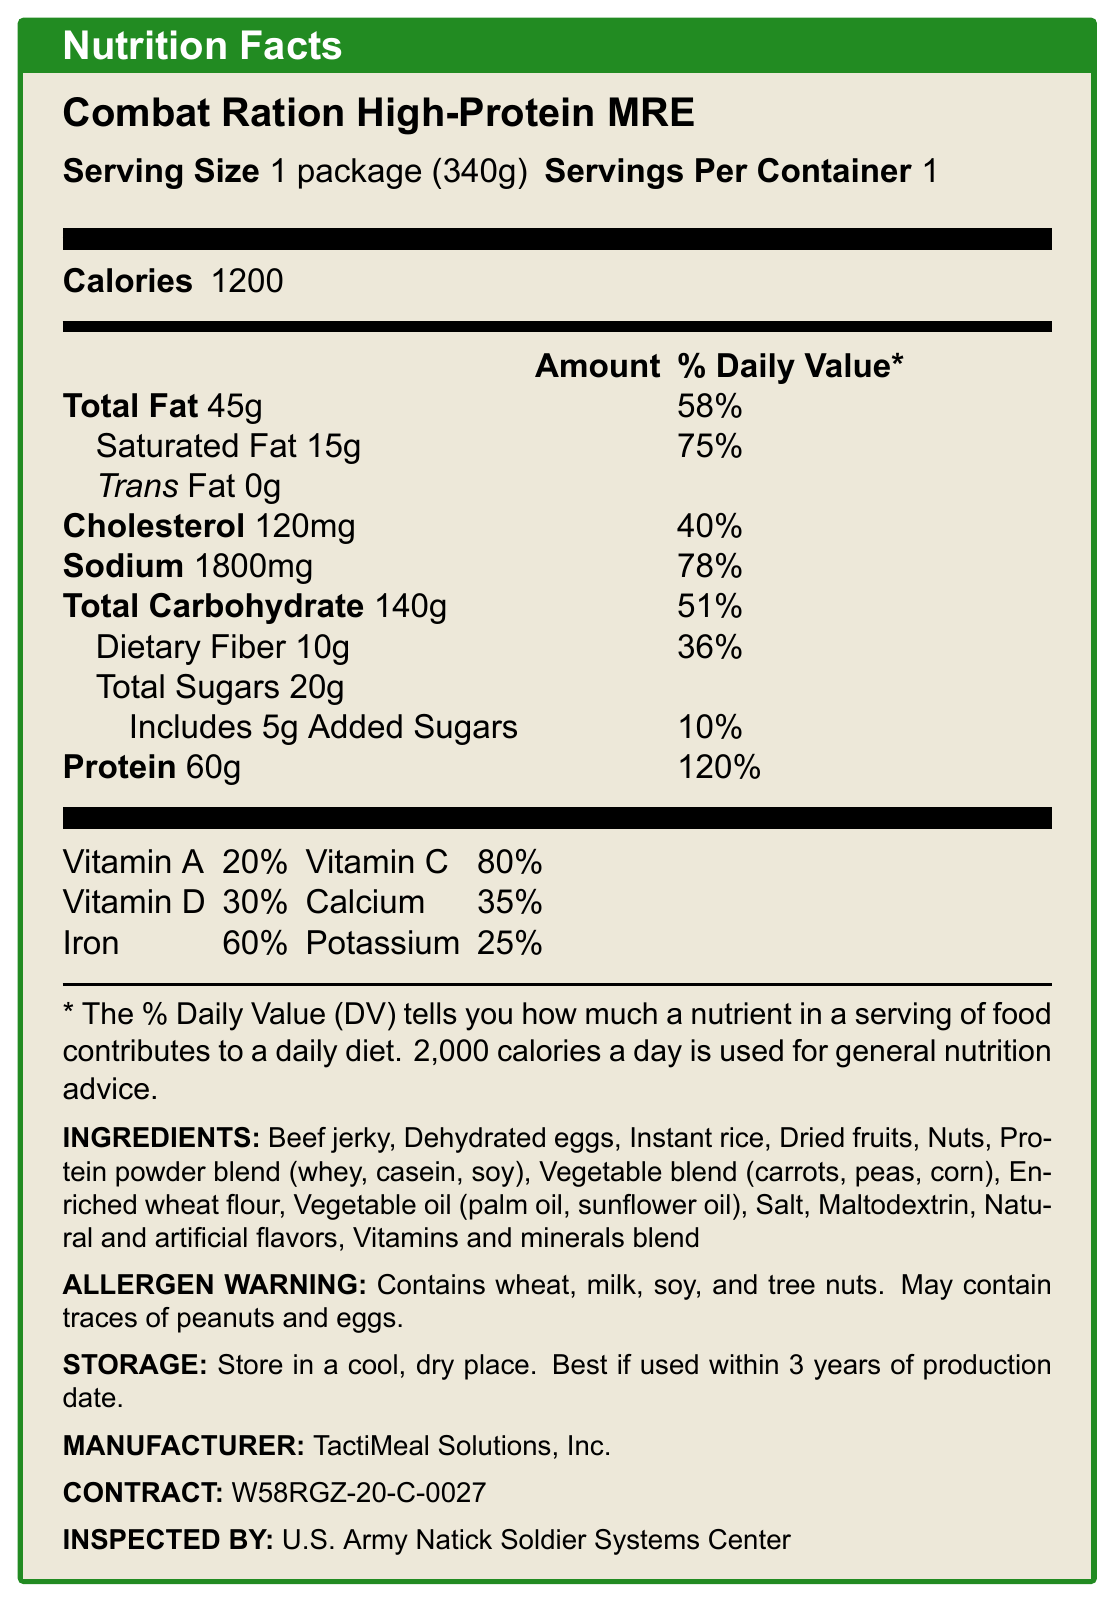what is the serving size of the Combat Ration High-Protein MRE? The document specifies that the serving size is 1 package (340g).
Answer: 1 package (340g) how many calories are in one serving of the Combat Ration High-Protein MRE? The document lists the calories per serving as 1200.
Answer: 1200 what is the total fat content in one serving, and what percentage of the daily value does it represent? The document states the total fat content as 45g, which represents 58% of the daily value.
Answer: 45g, 58% what is the main source of protein in the MRE? The ingredient list shows protein powder blend (whey, casein, soy) as a main source of protein.
Answer: Protein powder blend (whey, casein, soy) how much sodium does the MRE contain, and what percentage of the daily value does this represent? The document specifies the sodium content as 1800mg, which is 78% of the daily value.
Answer: 1800mg, 78% which vitamins are particularly abundant in this MRE? The document indicates that Vitamin C is at 80%, making it the most abundant vitamin listed.
Answer: Vitamin C how many grams of dietary fiber does the MRE contain? A. 5g B. 10g C. 15g D. 20g The document states that the MRE contains 10g of dietary fiber.
Answer: B. 10g what is the percentage of daily value for calcium provided by this MRE? A. 20% B. 35% C. 60% D. 25% The document shows that the percentage of the daily value for calcium is 35%.
Answer: B. 35% does the MRE contain trans fat? The document states the trans fat content as 0g.
Answer: No is the MRE designed to withstand extreme temperature conditions? The document mentions that it is heat-stable in various climate conditions and can resist temperatures from -60°F to 120°F.
Answer: Yes how long is the shelf life of the MRE at 80°F? The document states that the shelf life of the MRE at 80°F is a minimum of 3 years.
Answer: Minimum 3 years describe the purpose and special features of the Combat Ration High-Protein MRE. The document outlines several features, including sustained energy supply, essential vitamins and minerals, compactness, lightweight, and heat stability for extreme conditions.
Answer: The Combat Ration High-Protein MRE is developed for high-stress combat situations. It is designed to provide sustained energy for extended operations, fortified with essential vitamins and minerals for immune support, compact and lightweight for easy transport, and heat-stable in various climate conditions. who is the manufacturer of the Combat Ration High-Protein MRE? The document specifies that the manufacturer is TactiMeal Solutions, Inc.
Answer: TactiMeal Solutions, Inc. what distinguishes the Combat Ration High-Protein MRE from other civilian MREs? The document provides detailed information about this specific MRE but does not include a comparative analysis with civilian MREs to determine distinguishing features.
Answer: Cannot be determined what type of accessory pack is included in the MRE contents? The document lists the contents of the accessory pack, which includes utensils, salt, pepper, coffee, creamer, sugar, matches, and toilet paper.
Answer: Accessory pack includes utensils, salt, pepper, coffee, creamer, sugar, matches, and toilet paper. how many grams of added sugars are in the MRE, and what percentage of the daily value do they represent? The document specifies that there are 5g of added sugars, which is 10% of the daily value.
Answer: 5g, 10% what are the allergen warnings for this MRE? The document's allergen warning states that the MRE contains wheat, milk, soy, and tree nuts and may contain traces of peanuts and eggs.
Answer: Contains wheat, milk, soy, and tree nuts. May contain traces of peanuts and eggs. 